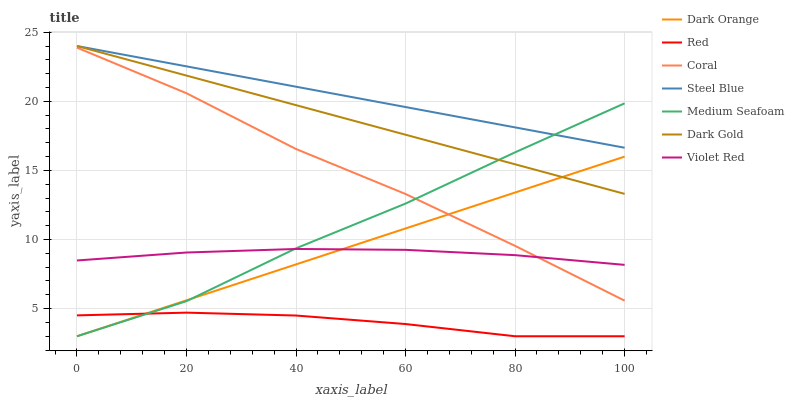Does Red have the minimum area under the curve?
Answer yes or no. Yes. Does Steel Blue have the maximum area under the curve?
Answer yes or no. Yes. Does Violet Red have the minimum area under the curve?
Answer yes or no. No. Does Violet Red have the maximum area under the curve?
Answer yes or no. No. Is Dark Orange the smoothest?
Answer yes or no. Yes. Is Medium Seafoam the roughest?
Answer yes or no. Yes. Is Violet Red the smoothest?
Answer yes or no. No. Is Violet Red the roughest?
Answer yes or no. No. Does Dark Orange have the lowest value?
Answer yes or no. Yes. Does Violet Red have the lowest value?
Answer yes or no. No. Does Steel Blue have the highest value?
Answer yes or no. Yes. Does Violet Red have the highest value?
Answer yes or no. No. Is Red less than Coral?
Answer yes or no. Yes. Is Steel Blue greater than Coral?
Answer yes or no. Yes. Does Dark Gold intersect Medium Seafoam?
Answer yes or no. Yes. Is Dark Gold less than Medium Seafoam?
Answer yes or no. No. Is Dark Gold greater than Medium Seafoam?
Answer yes or no. No. Does Red intersect Coral?
Answer yes or no. No. 